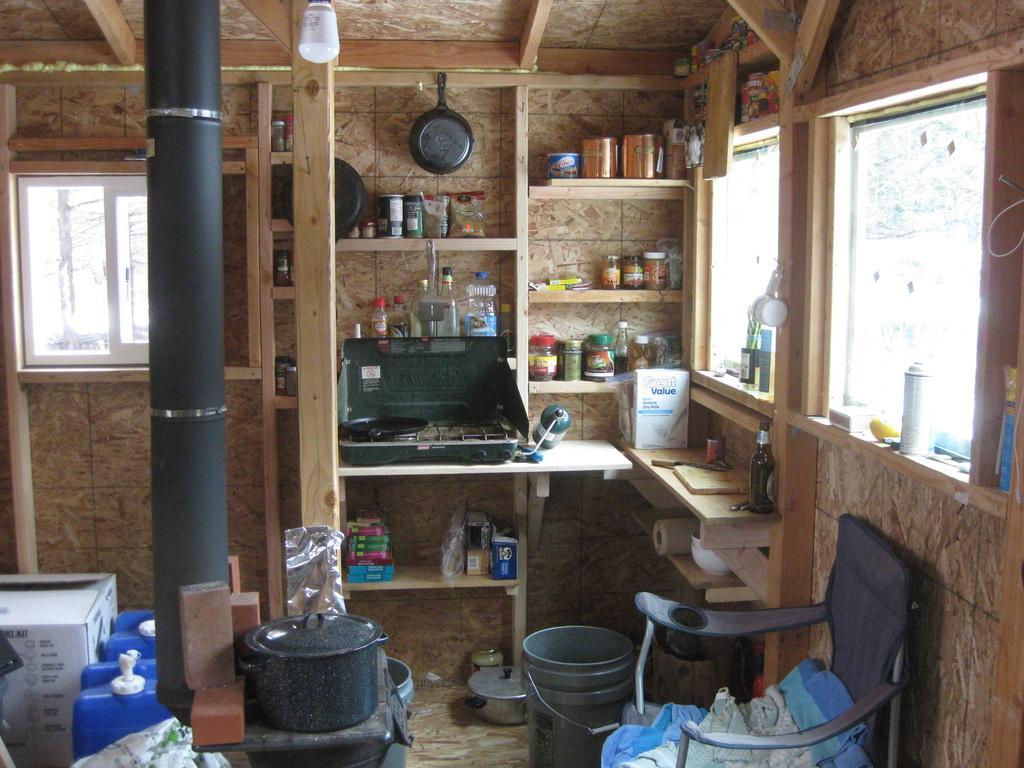Describe this image in one or two sentences. In this image we can see a inside view of a room. In the middle of the image we can see group of vessels,buckets ,containers a chair placed on the floor. In the background ,we can see window ,light group of trees. 